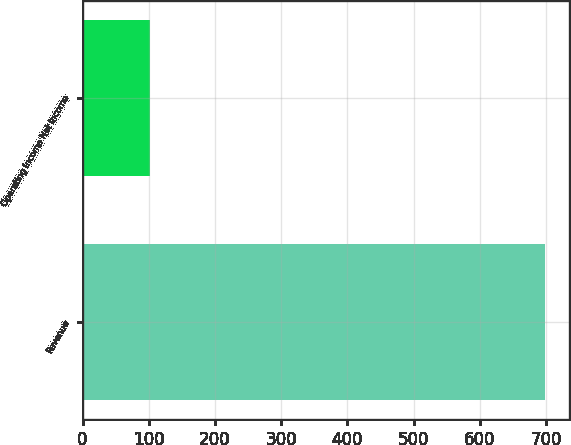Convert chart. <chart><loc_0><loc_0><loc_500><loc_500><bar_chart><fcel>Revenue<fcel>Operating income Net income<nl><fcel>699.2<fcel>102.2<nl></chart> 